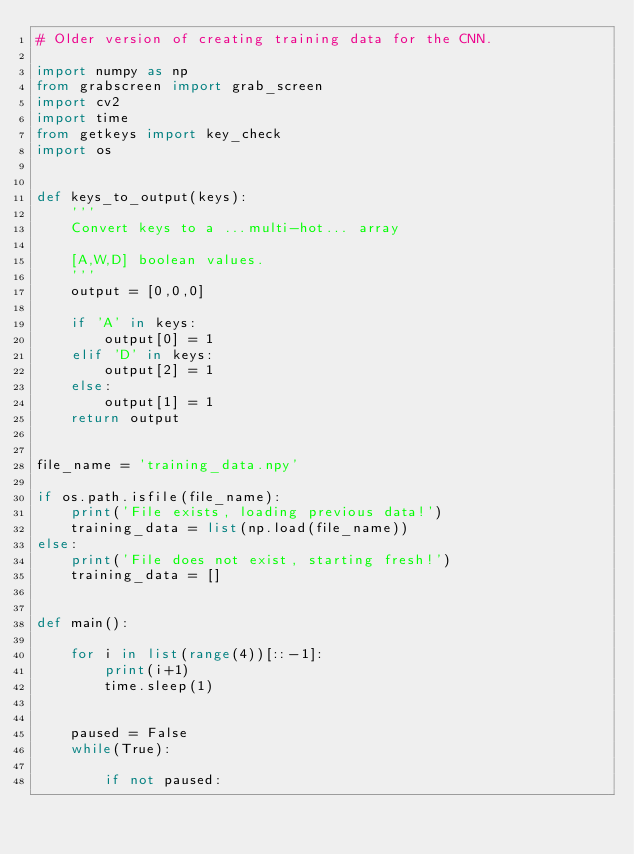<code> <loc_0><loc_0><loc_500><loc_500><_Python_># Older version of creating training data for the CNN.

import numpy as np
from grabscreen import grab_screen
import cv2
import time
from getkeys import key_check
import os


def keys_to_output(keys):
    '''
    Convert keys to a ...multi-hot... array

    [A,W,D] boolean values.
    '''
    output = [0,0,0]

    if 'A' in keys:
        output[0] = 1
    elif 'D' in keys:
        output[2] = 1
    else:
        output[1] = 1
    return output


file_name = 'training_data.npy'

if os.path.isfile(file_name):
    print('File exists, loading previous data!')
    training_data = list(np.load(file_name))
else:
    print('File does not exist, starting fresh!')
    training_data = []


def main():

    for i in list(range(4))[::-1]:
        print(i+1)
        time.sleep(1)


    paused = False
    while(True):

        if not paused:</code> 